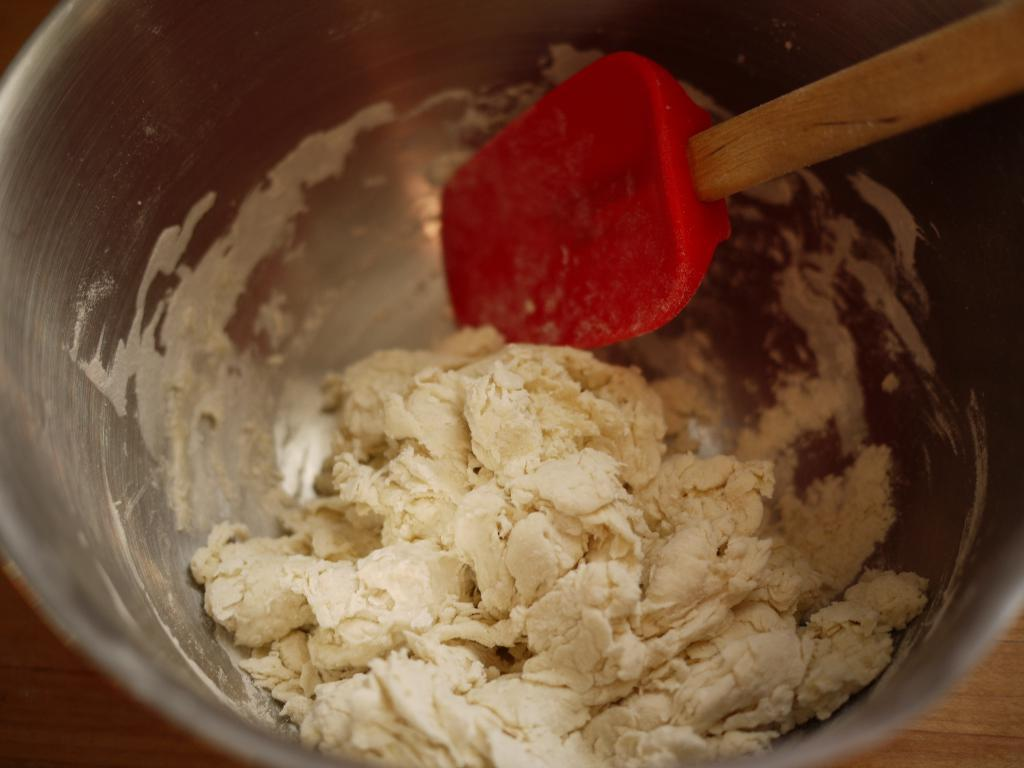What is the main subject of the image? The main subject of the image is bread dough. Where is the bread dough located? The bread dough is in a bowl. What tool is being used to mix the bread dough? A spatula is being used to mix the bread dough. What type of jail is depicted in the image? There is no jail present in the image; it features bread dough in a bowl being mixed with a spatula. What idea is being discussed in the image? The image does not depict a discussion or an idea; it shows bread dough being mixed with a spatula. 